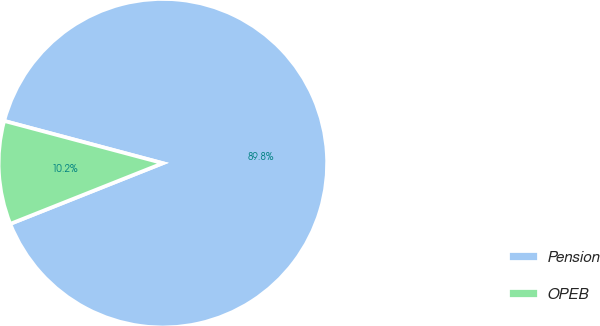<chart> <loc_0><loc_0><loc_500><loc_500><pie_chart><fcel>Pension<fcel>OPEB<nl><fcel>89.83%<fcel>10.17%<nl></chart> 